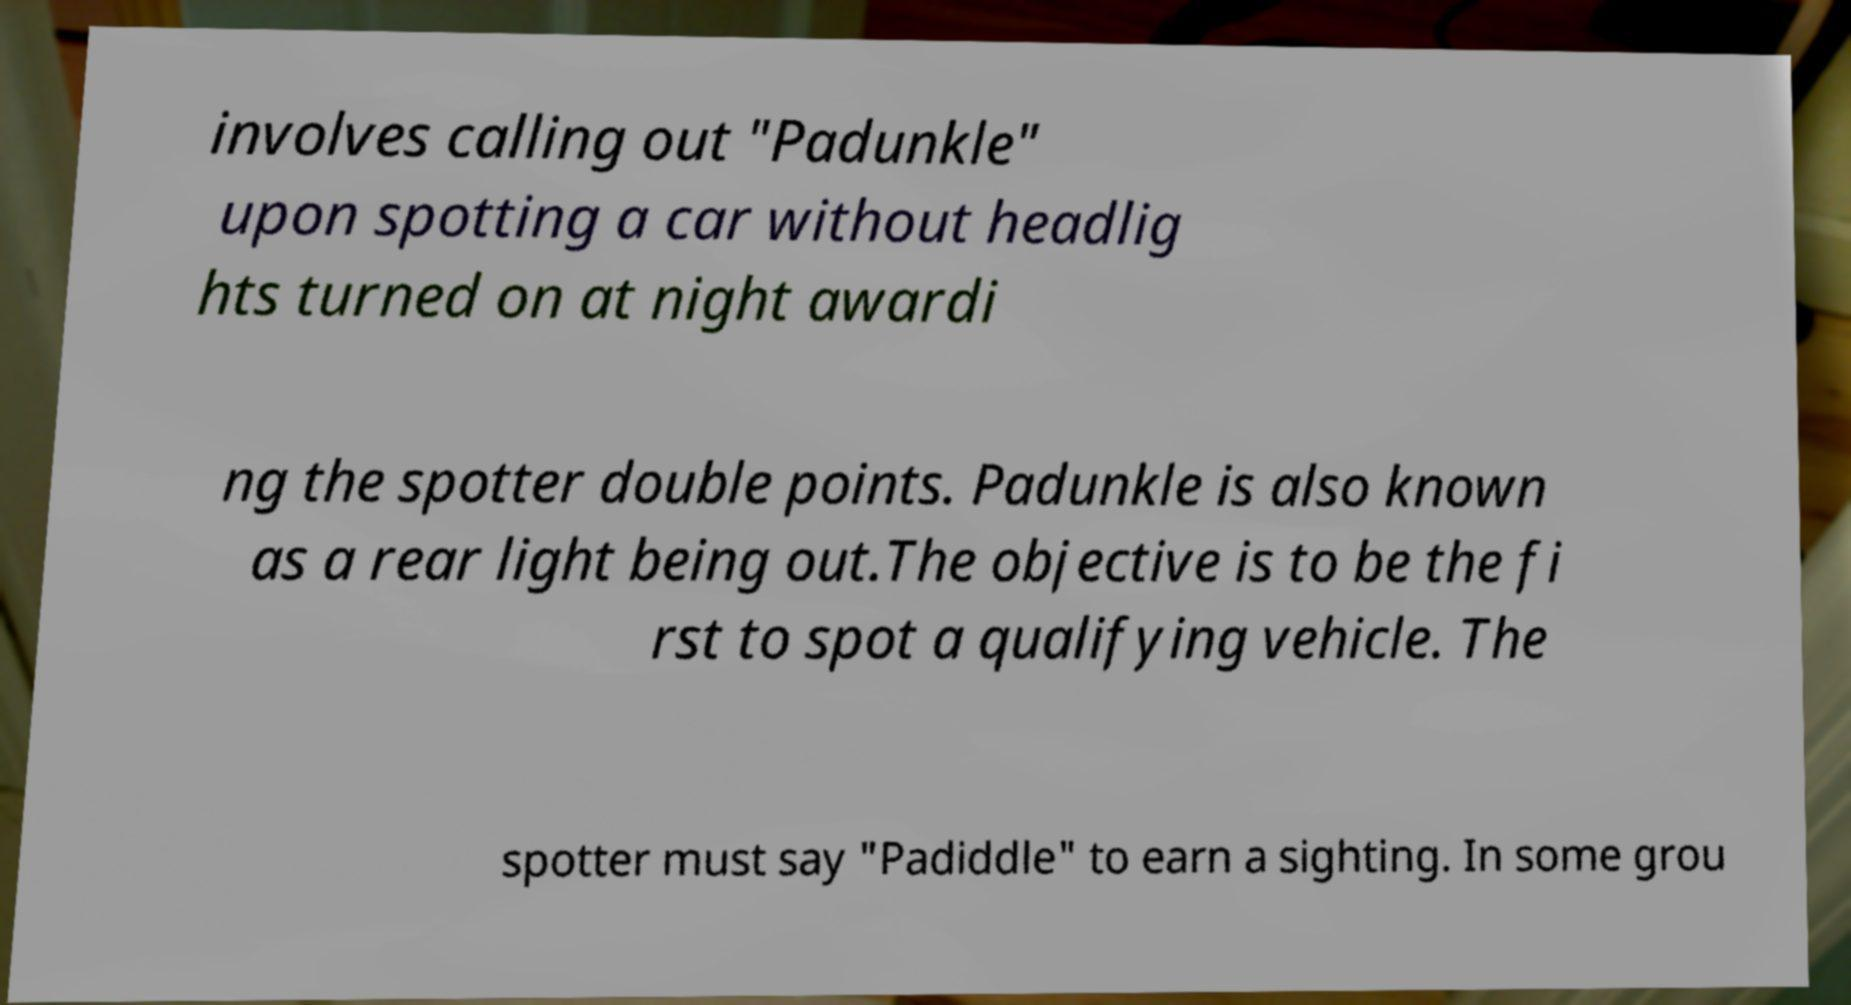There's text embedded in this image that I need extracted. Can you transcribe it verbatim? involves calling out "Padunkle" upon spotting a car without headlig hts turned on at night awardi ng the spotter double points. Padunkle is also known as a rear light being out.The objective is to be the fi rst to spot a qualifying vehicle. The spotter must say "Padiddle" to earn a sighting. In some grou 